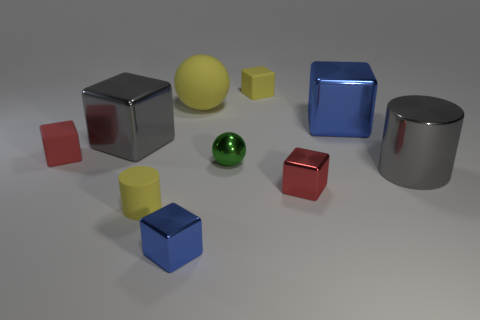Subtract all red cubes. How many cubes are left? 4 Subtract all small red matte blocks. How many blocks are left? 5 Subtract all cyan cubes. Subtract all green cylinders. How many cubes are left? 6 Subtract all cylinders. How many objects are left? 8 Subtract 0 blue balls. How many objects are left? 10 Subtract all big green rubber cylinders. Subtract all yellow objects. How many objects are left? 7 Add 4 big objects. How many big objects are left? 8 Add 2 small blue rubber things. How many small blue rubber things exist? 2 